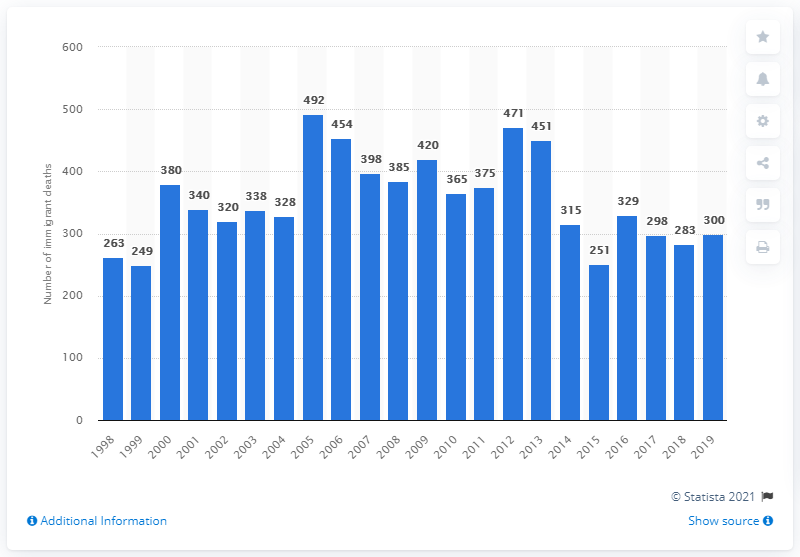Point out several critical features in this image. In fiscal year 2019, there were approximately 300 immigrants who died near the southwest border. 